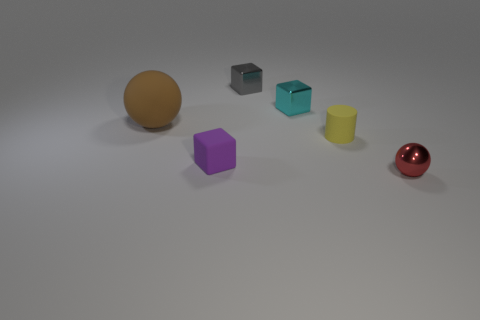Add 4 large cubes. How many objects exist? 10 Subtract all cylinders. How many objects are left? 5 Add 3 large yellow rubber balls. How many large yellow rubber balls exist? 3 Subtract 1 yellow cylinders. How many objects are left? 5 Subtract all big brown matte things. Subtract all matte cubes. How many objects are left? 4 Add 6 yellow rubber cylinders. How many yellow rubber cylinders are left? 7 